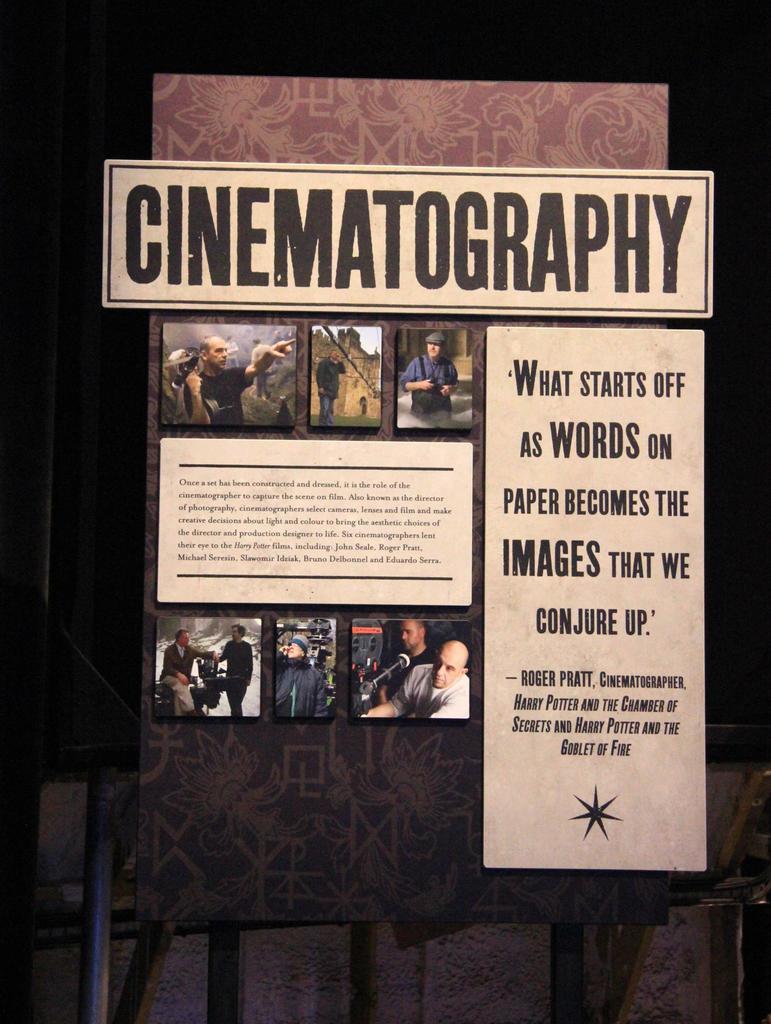What is this board talking about?
Your response must be concise. Cinematography. What is the title?
Make the answer very short. Cinematography. 